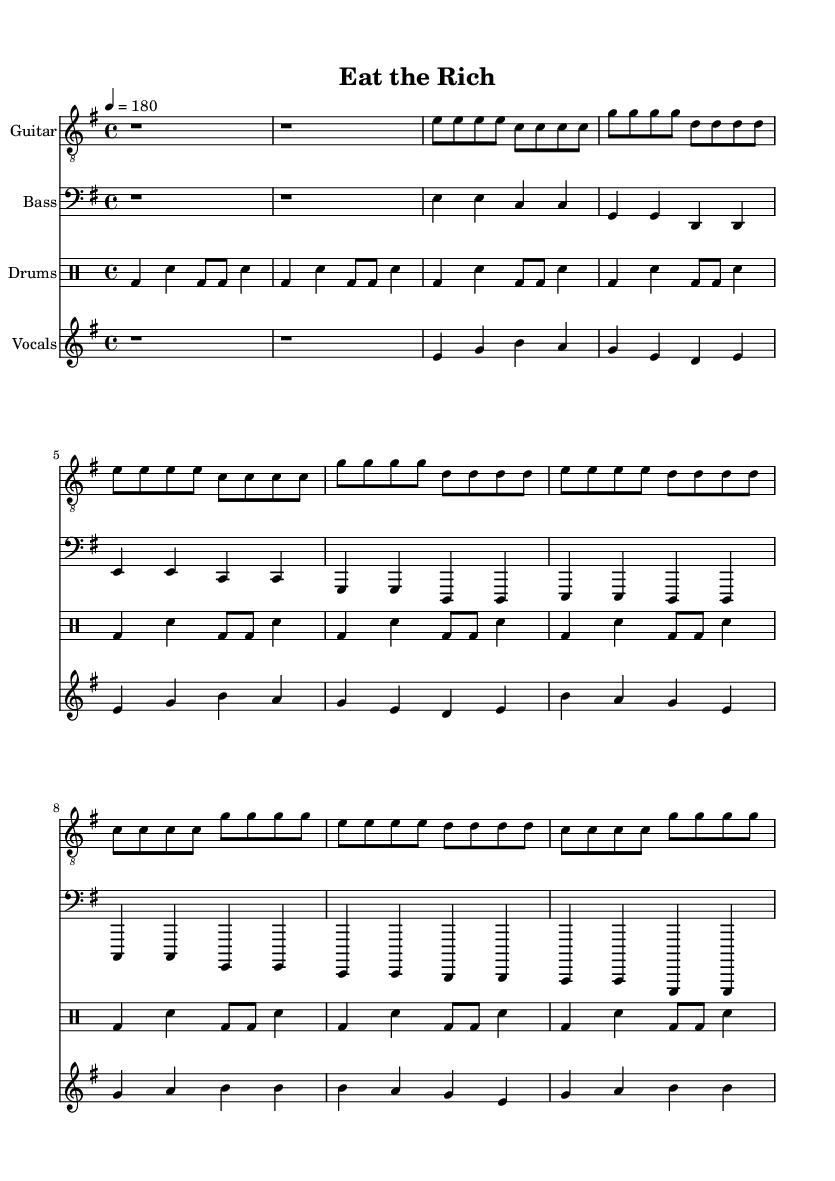What is the key signature of this music? The key signature is E minor, which is indicated by one sharp (F sharp) shown at the beginning of the sheet music.
Answer: E minor What is the time signature? The time signature is 4/4, meaning there are four beats in each measure and the quarter note receives one beat, as stated in the beginning of the music.
Answer: 4/4 What is the tempo marking? The tempo marking is 180 beats per minute, indicated by the text "4 = 180" which shows the speed of the piece.
Answer: 180 How many measures are in the verse? The verse consists of 8 measures, as indicated by the structure of the notation where each line breaks into 4 measures, and there are two identical sections in the verse.
Answer: 8 How many times does the chorus repeat? The chorus repeats twice; you can see it written out for the first time and then again, providing the same lines of melody and lyrics indicated clearly in the score.
Answer: Twice What is the main theme of the lyrics? The main theme of the lyrics is addressing social and economic disparities, calling for action against wealth inequality as articulated in the phrases of the lyrics provided.
Answer: Wealth inequality 